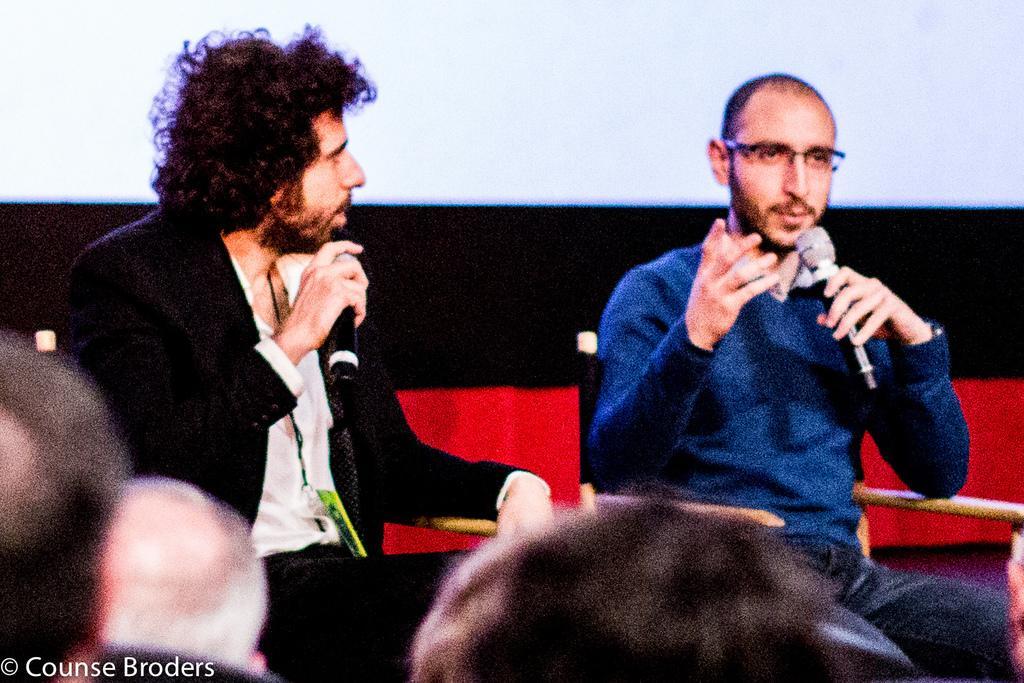Please provide a concise description of this image. In this picture we can see two persons sitting on chair holding mics in their hands and talking and in front of them there are some people and in background we can see wall. 